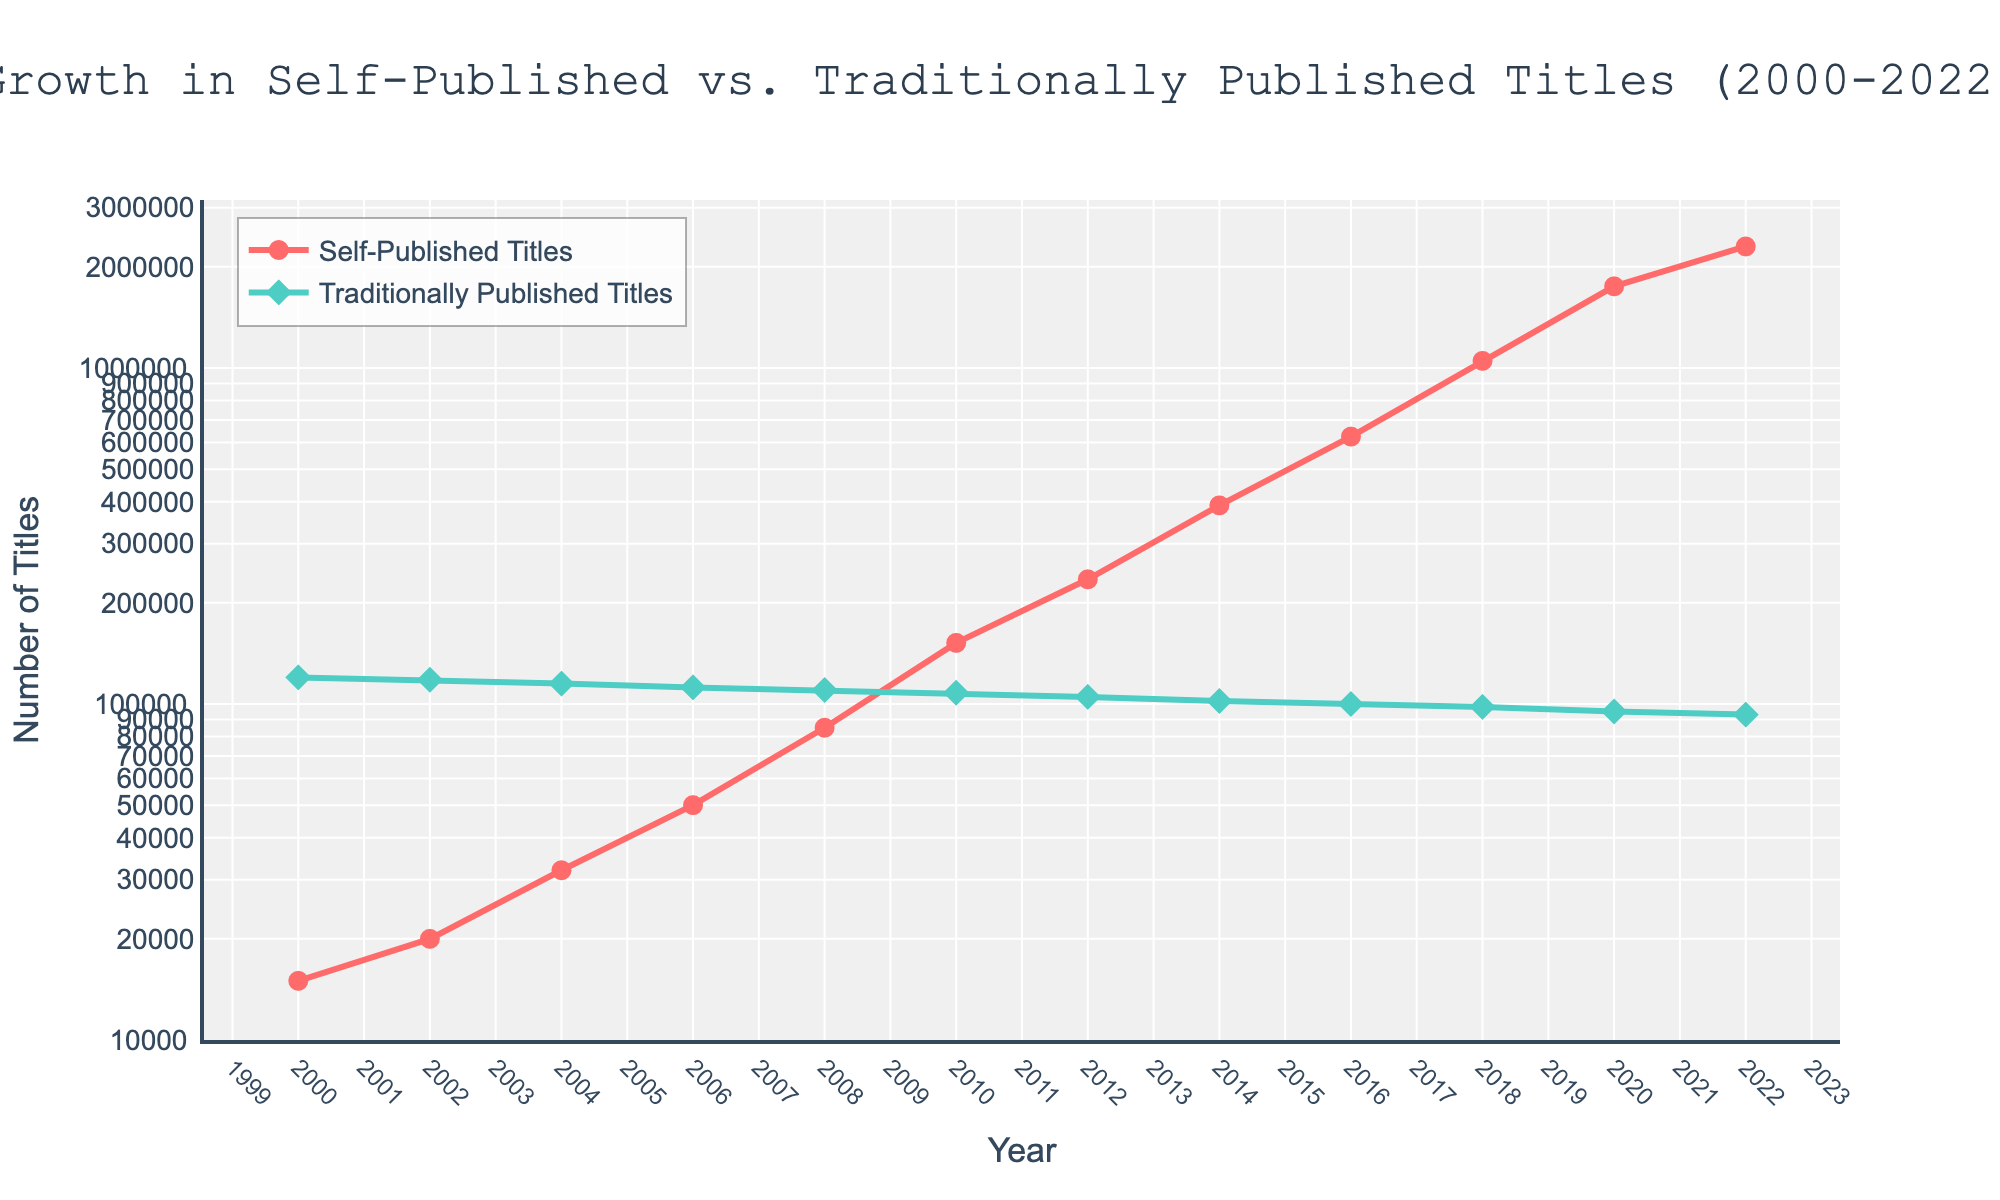What is the difference in the number of self-published titles between 2000 and 2022? To find the difference, subtract the number of self-published titles in 2000 from the number in 2022. This is 2,300,000 - 15,000 = 2,285,000.
Answer: 2,285,000 By how much did the number of traditionally published titles decline from 2000 to 2022? To calculate the decline, subtract the number of traditionally published titles in 2022 from the number in 2000. This is 120,000 - 93,000 = 27,000.
Answer: 27,000 In which year did the number of self-published titles surpass the number of traditionally published titles? By examining the chart, we identify that around 2016 the self-published titles (625,000) surpass the traditionally published titles (100,000).
Answer: 2016 What is the percentage growth in self-published titles from 2000 to 2020? First calculate the difference in the number of self-published titles between 2000 and 2020: 1,750,000 - 15,000 = 1,735,000. Then, divide this difference by the number of self-published titles in 2000 and multiply by 100 to obtain the percentage: (1,735,000 / 15,000) * 100 = 11,566.67%.
Answer: 11,566.67% Which trend line (self-published or traditionally published) has a steeper slope after 2010? The slope of the trend line indicates the rate of change. The self-published titles line shows a sharper upward trend compared to the traditionally published titles line after 2010.
Answer: self-published What does the annotation "Self-publishing boom" refer to in the figure? The annotation "Self-publishing boom" refers to the rapid increase in the number of self-published titles around the year 2022, visibly highlighted by a sharp rise in the line representing self-published titles.
Answer: Rapid increase in self-published titles around 2022 Between which consecutive years did traditionally published titles have the smallest decline? By checking the chart, from 2004 to 2006, the number of traditionally published titles decreased minimally from 115,000 to 112,000, showing the smallest decline of 3,000 titles.
Answer: 2004-2006 What is the average annual growth rate of self-published titles from 2000 to 2022? First, compute the total growth in self-published titles from 2000 to 2022: 2,300,000 - 15,000 = 2,285,000. Then, divide this by the number of years (2022-2000), which is 22. The average annual growth is 2,285,000 / 22 = 103,863.64.
Answer: 103,863.64 